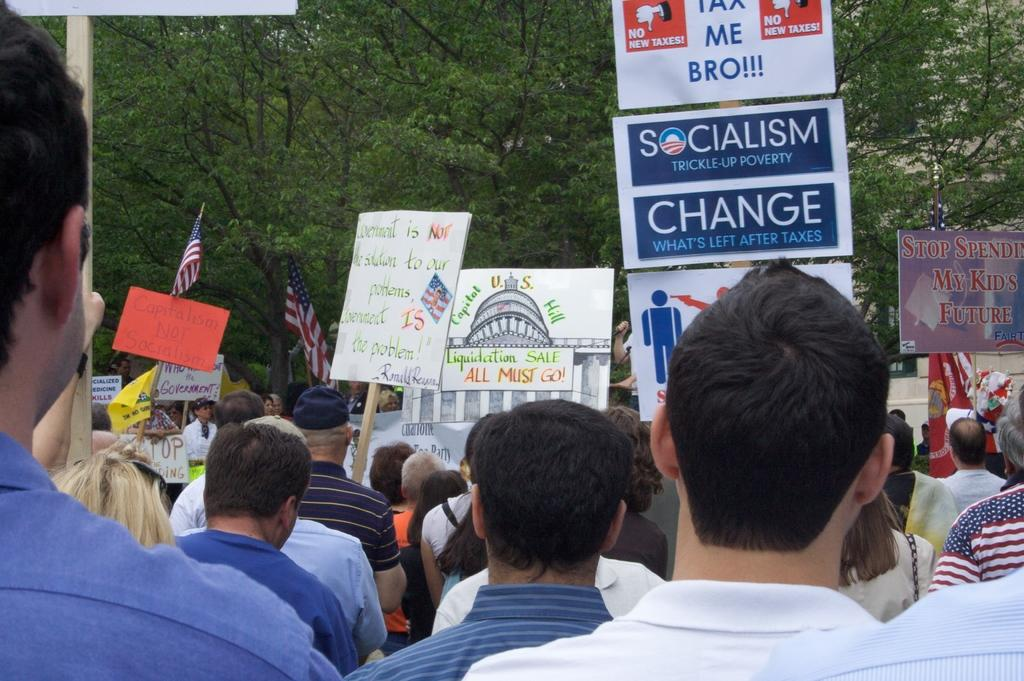What are the people in the image doing? The people in the image are standing. What are some of the people holding in the image? Some people are holding flags, while others are holding boards with text and images. What can be seen in the background of the image? There are trees in the background of the image. What type of disease is being treated by the brothers in the image? There are no brothers or disease mentioned in the image. The image only shows people standing, some holding flags and boards with text and images, with trees in the background. 